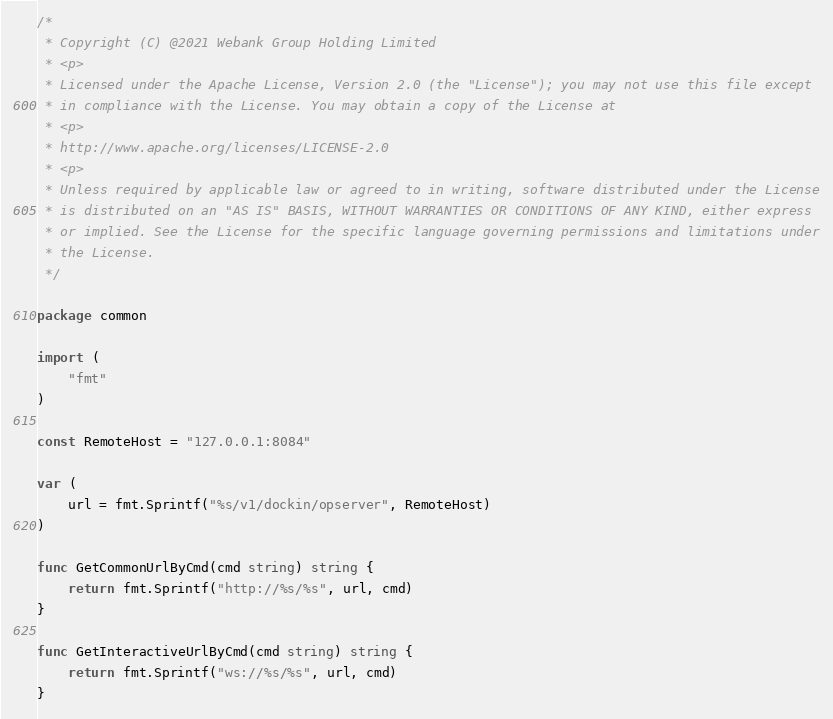<code> <loc_0><loc_0><loc_500><loc_500><_Go_>/*
 * Copyright (C) @2021 Webank Group Holding Limited
 * <p>
 * Licensed under the Apache License, Version 2.0 (the "License"); you may not use this file except
 * in compliance with the License. You may obtain a copy of the License at
 * <p>
 * http://www.apache.org/licenses/LICENSE-2.0
 * <p>
 * Unless required by applicable law or agreed to in writing, software distributed under the License
 * is distributed on an "AS IS" BASIS, WITHOUT WARRANTIES OR CONDITIONS OF ANY KIND, either express
 * or implied. See the License for the specific language governing permissions and limitations under
 * the License.
 */

package common

import (
	"fmt"
)

const RemoteHost = "127.0.0.1:8084"

var (
	url = fmt.Sprintf("%s/v1/dockin/opserver", RemoteHost)
)

func GetCommonUrlByCmd(cmd string) string {
	return fmt.Sprintf("http://%s/%s", url, cmd)
}

func GetInteractiveUrlByCmd(cmd string) string {
	return fmt.Sprintf("ws://%s/%s", url, cmd)
}
</code> 